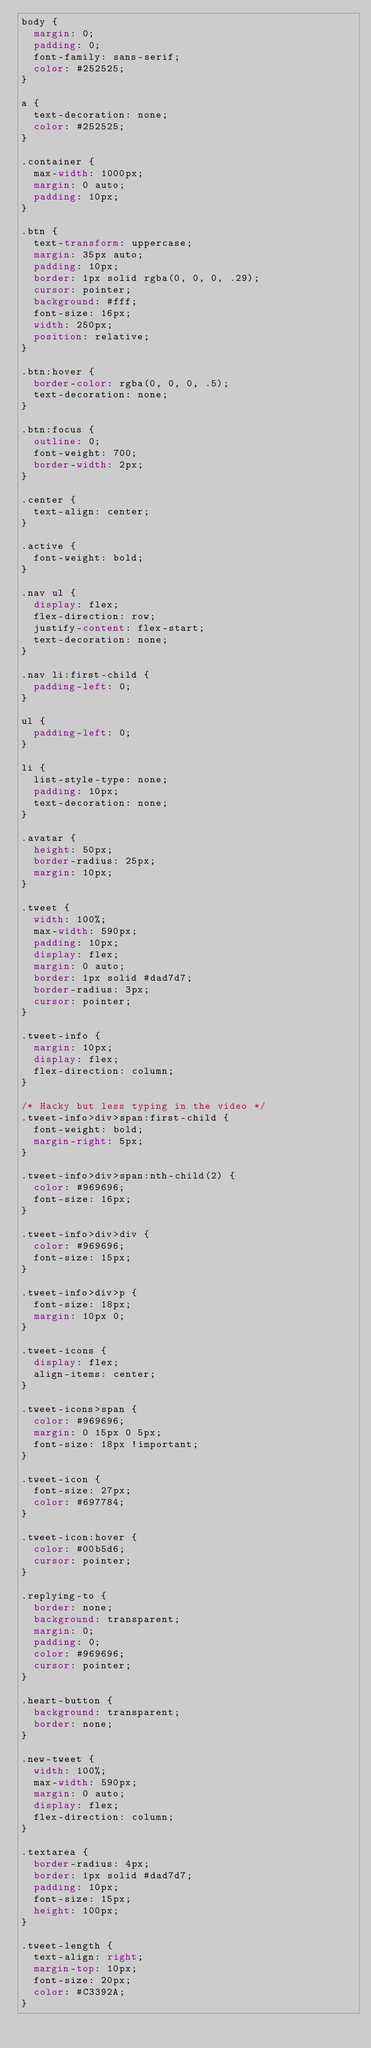Convert code to text. <code><loc_0><loc_0><loc_500><loc_500><_CSS_>body {
  margin: 0;
  padding: 0;
  font-family: sans-serif;
  color: #252525;
}

a {
  text-decoration: none;
  color: #252525;
}

.container {
  max-width: 1000px;
  margin: 0 auto;
  padding: 10px;
}

.btn {
  text-transform: uppercase;
  margin: 35px auto;
  padding: 10px;
  border: 1px solid rgba(0, 0, 0, .29);
  cursor: pointer;
  background: #fff;
  font-size: 16px;
  width: 250px;
  position: relative;
}

.btn:hover {
  border-color: rgba(0, 0, 0, .5);
  text-decoration: none;
}

.btn:focus {
  outline: 0;
  font-weight: 700;
  border-width: 2px;
}

.center {
  text-align: center;
}

.active {
  font-weight: bold;
}

.nav ul {
  display: flex;
  flex-direction: row;
  justify-content: flex-start;
  text-decoration: none;
}

.nav li:first-child {
  padding-left: 0;
}

ul {
  padding-left: 0;
}

li {
  list-style-type: none;
  padding: 10px;
  text-decoration: none;
}

.avatar {
  height: 50px;
  border-radius: 25px;
  margin: 10px;
}

.tweet {
  width: 100%;
  max-width: 590px;
  padding: 10px;
  display: flex;
  margin: 0 auto;
  border: 1px solid #dad7d7;
  border-radius: 3px;
  cursor: pointer;
}

.tweet-info {
  margin: 10px;
  display: flex;
  flex-direction: column;
}

/* Hacky but less typing in the video */
.tweet-info>div>span:first-child {
  font-weight: bold;
  margin-right: 5px;
}

.tweet-info>div>span:nth-child(2) {
  color: #969696;
  font-size: 16px;
}

.tweet-info>div>div {
  color: #969696;
  font-size: 15px;
}

.tweet-info>div>p {
  font-size: 18px;
  margin: 10px 0;
}

.tweet-icons {
  display: flex;
  align-items: center;
}

.tweet-icons>span {
  color: #969696;
  margin: 0 15px 0 5px;
  font-size: 18px !important;
}

.tweet-icon {
  font-size: 27px;
  color: #697784;
}

.tweet-icon:hover {
  color: #00b5d6;
  cursor: pointer;
}

.replying-to {
  border: none;
  background: transparent;
  margin: 0;
  padding: 0;
  color: #969696;
  cursor: pointer;
}

.heart-button {
  background: transparent;
  border: none;
}

.new-tweet {
  width: 100%;
  max-width: 590px;
  margin: 0 auto;
  display: flex;
  flex-direction: column;
}

.textarea {
  border-radius: 4px;
  border: 1px solid #dad7d7;
  padding: 10px;
  font-size: 15px;
  height: 100px;
}

.tweet-length {
  text-align: right;
  margin-top: 10px;
  font-size: 20px;
  color: #C3392A;
}
</code> 